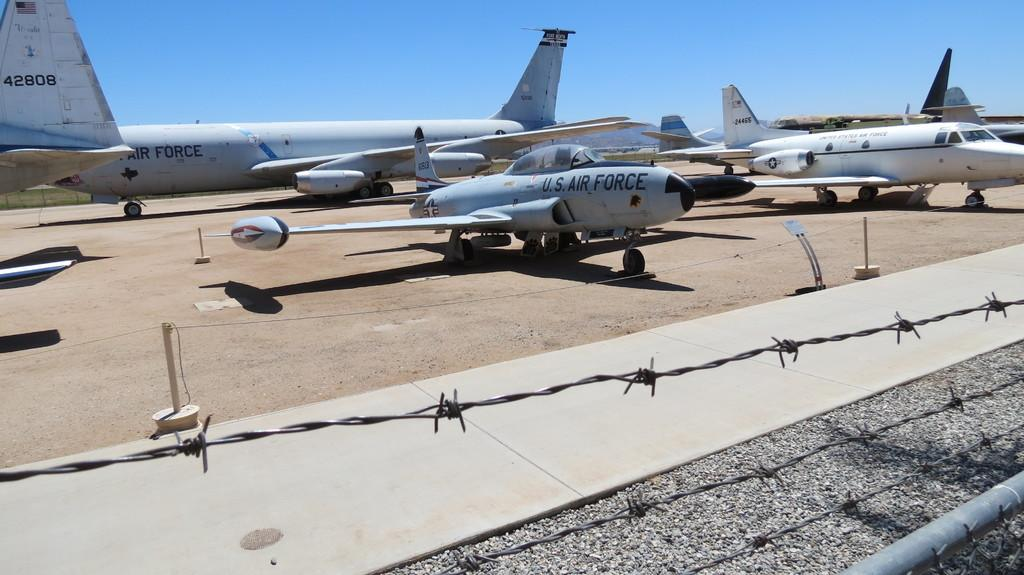<image>
Offer a succinct explanation of the picture presented. Several US Air Force jets on a runway 